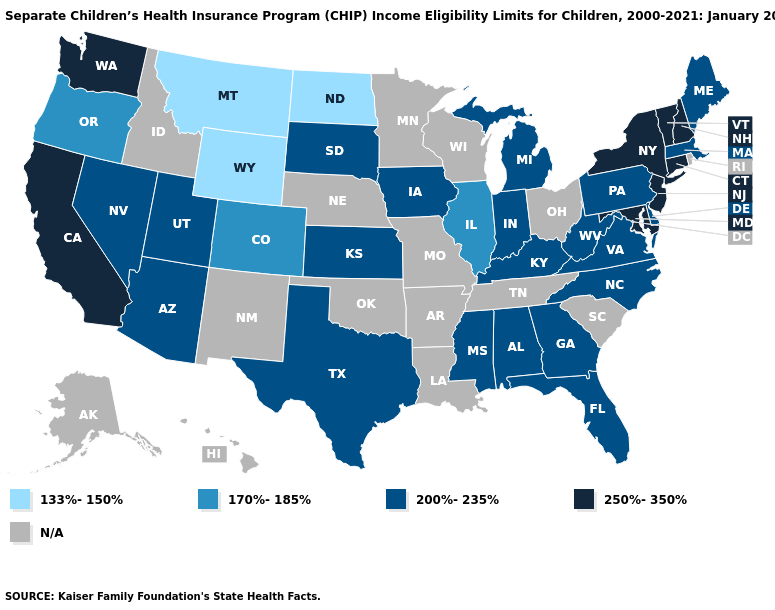Does Maine have the lowest value in the USA?
Quick response, please. No. Among the states that border Rhode Island , which have the highest value?
Concise answer only. Connecticut. Does Massachusetts have the lowest value in the Northeast?
Short answer required. Yes. What is the value of Colorado?
Concise answer only. 170%-185%. What is the value of Idaho?
Be succinct. N/A. Name the states that have a value in the range 200%-235%?
Answer briefly. Alabama, Arizona, Delaware, Florida, Georgia, Indiana, Iowa, Kansas, Kentucky, Maine, Massachusetts, Michigan, Mississippi, Nevada, North Carolina, Pennsylvania, South Dakota, Texas, Utah, Virginia, West Virginia. Does the first symbol in the legend represent the smallest category?
Quick response, please. Yes. What is the value of Iowa?
Keep it brief. 200%-235%. Is the legend a continuous bar?
Short answer required. No. Does Iowa have the lowest value in the USA?
Give a very brief answer. No. What is the value of New Hampshire?
Be succinct. 250%-350%. Name the states that have a value in the range 200%-235%?
Short answer required. Alabama, Arizona, Delaware, Florida, Georgia, Indiana, Iowa, Kansas, Kentucky, Maine, Massachusetts, Michigan, Mississippi, Nevada, North Carolina, Pennsylvania, South Dakota, Texas, Utah, Virginia, West Virginia. 